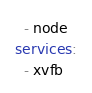<code> <loc_0><loc_0><loc_500><loc_500><_YAML_>  - node
services:
  - xvfb
</code> 